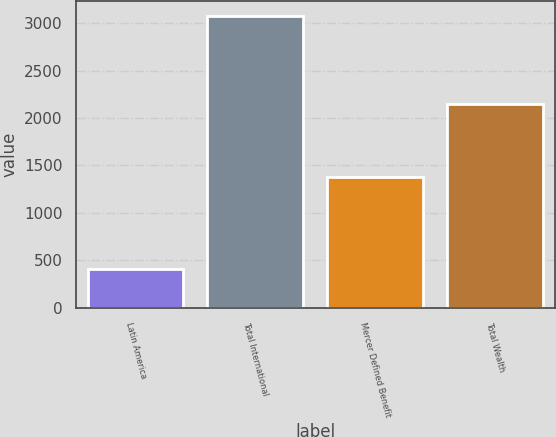Convert chart to OTSL. <chart><loc_0><loc_0><loc_500><loc_500><bar_chart><fcel>Latin America<fcel>Total International<fcel>Mercer Defined Benefit<fcel>Total Wealth<nl><fcel>404<fcel>3082<fcel>1381<fcel>2148<nl></chart> 